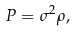Convert formula to latex. <formula><loc_0><loc_0><loc_500><loc_500>P = \sigma ^ { 2 } \rho ,</formula> 